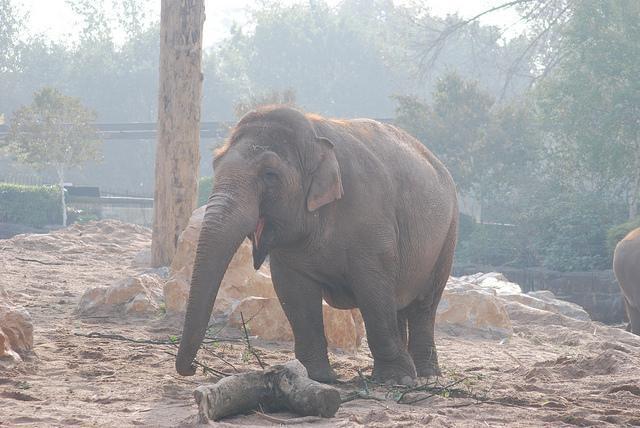How many elephants are there?
Give a very brief answer. 2. 